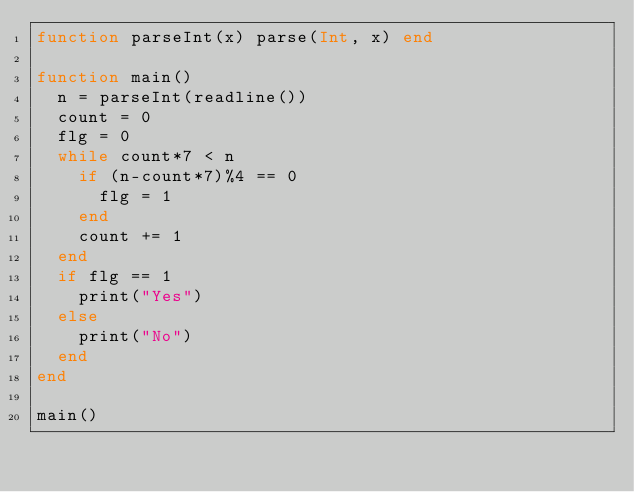Convert code to text. <code><loc_0><loc_0><loc_500><loc_500><_Julia_>function parseInt(x) parse(Int, x) end

function main()
	n = parseInt(readline())
	count = 0
	flg = 0
	while count*7 < n
		if (n-count*7)%4 == 0
			flg = 1
		end
		count += 1
	end
	if flg == 1
		print("Yes")
	else
		print("No")
	end
end

main()</code> 